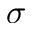Convert formula to latex. <formula><loc_0><loc_0><loc_500><loc_500>\sigma</formula> 